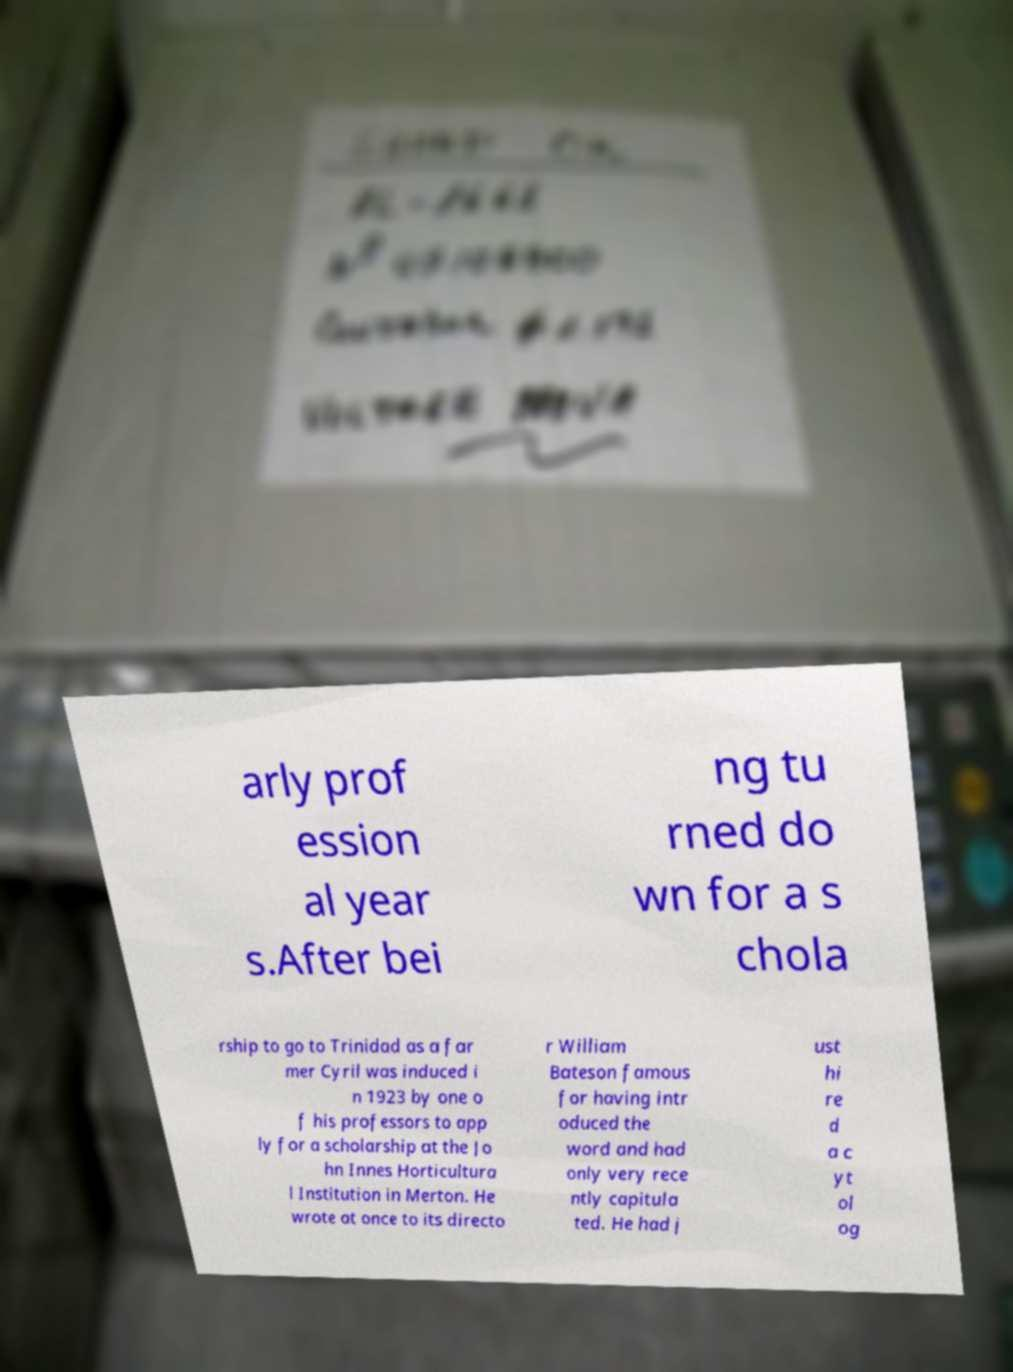Could you extract and type out the text from this image? arly prof ession al year s.After bei ng tu rned do wn for a s chola rship to go to Trinidad as a far mer Cyril was induced i n 1923 by one o f his professors to app ly for a scholarship at the Jo hn Innes Horticultura l Institution in Merton. He wrote at once to its directo r William Bateson famous for having intr oduced the word and had only very rece ntly capitula ted. He had j ust hi re d a c yt ol og 